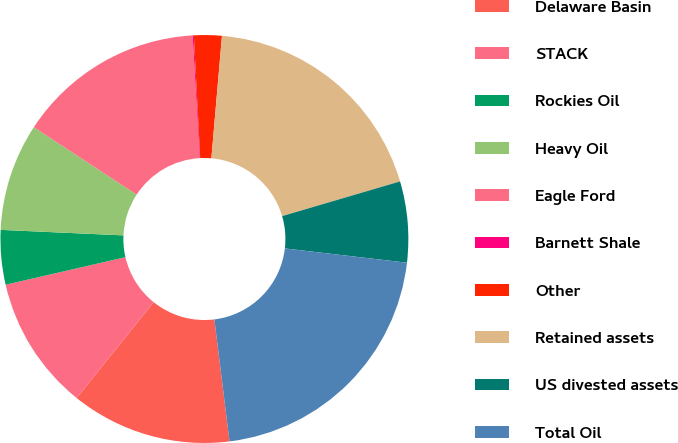Convert chart to OTSL. <chart><loc_0><loc_0><loc_500><loc_500><pie_chart><fcel>Delaware Basin<fcel>STACK<fcel>Rockies Oil<fcel>Heavy Oil<fcel>Eagle Ford<fcel>Barnett Shale<fcel>Other<fcel>Retained assets<fcel>US divested assets<fcel>Total Oil<nl><fcel>12.74%<fcel>10.63%<fcel>4.31%<fcel>8.52%<fcel>14.85%<fcel>0.09%<fcel>2.2%<fcel>19.07%<fcel>6.41%<fcel>21.18%<nl></chart> 